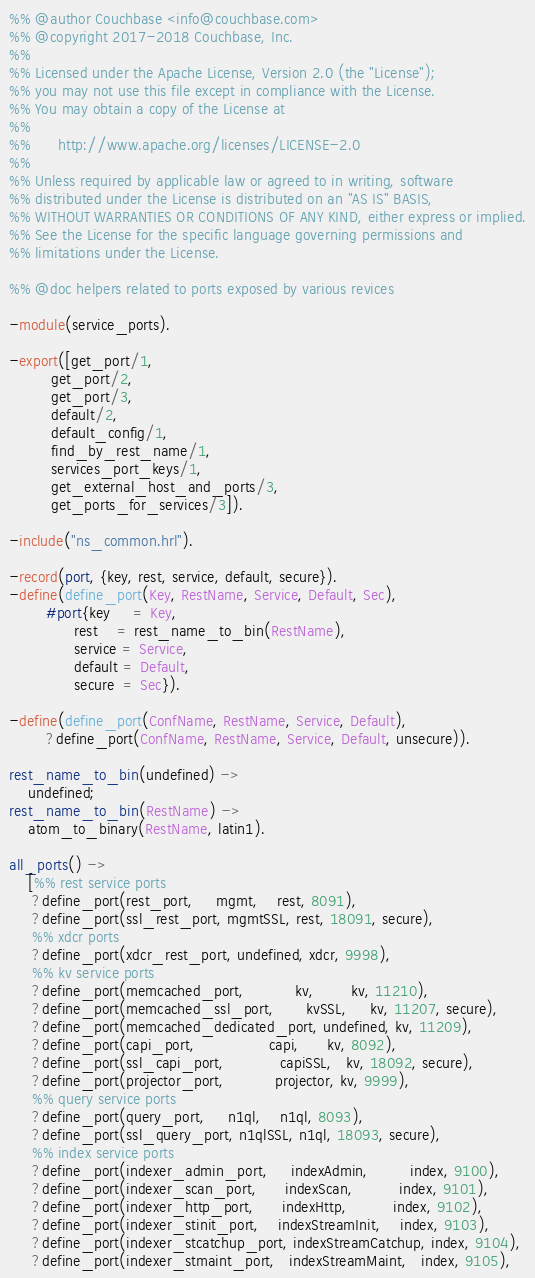<code> <loc_0><loc_0><loc_500><loc_500><_Erlang_>%% @author Couchbase <info@couchbase.com>
%% @copyright 2017-2018 Couchbase, Inc.
%%
%% Licensed under the Apache License, Version 2.0 (the "License");
%% you may not use this file except in compliance with the License.
%% You may obtain a copy of the License at
%%
%%      http://www.apache.org/licenses/LICENSE-2.0
%%
%% Unless required by applicable law or agreed to in writing, software
%% distributed under the License is distributed on an "AS IS" BASIS,
%% WITHOUT WARRANTIES OR CONDITIONS OF ANY KIND, either express or implied.
%% See the License for the specific language governing permissions and
%% limitations under the License.

%% @doc helpers related to ports exposed by various revices

-module(service_ports).

-export([get_port/1,
         get_port/2,
         get_port/3,
         default/2,
         default_config/1,
         find_by_rest_name/1,
         services_port_keys/1,
         get_external_host_and_ports/3,
         get_ports_for_services/3]).

-include("ns_common.hrl").

-record(port, {key, rest, service, default, secure}).
-define(define_port(Key, RestName, Service, Default, Sec),
        #port{key     = Key,
              rest    = rest_name_to_bin(RestName),
              service = Service,
              default = Default,
              secure  = Sec}).

-define(define_port(ConfName, RestName, Service, Default),
        ?define_port(ConfName, RestName, Service, Default, unsecure)).

rest_name_to_bin(undefined) ->
    undefined;
rest_name_to_bin(RestName) ->
    atom_to_binary(RestName, latin1).

all_ports() ->
    [%% rest service ports
     ?define_port(rest_port,     mgmt,    rest, 8091),
     ?define_port(ssl_rest_port, mgmtSSL, rest, 18091, secure),
     %% xdcr ports
     ?define_port(xdcr_rest_port, undefined, xdcr, 9998),
     %% kv service ports
     ?define_port(memcached_port,           kv,        kv, 11210),
     ?define_port(memcached_ssl_port,       kvSSL,     kv, 11207, secure),
     ?define_port(memcached_dedicated_port, undefined, kv, 11209),
     ?define_port(capi_port,                capi,      kv, 8092),
     ?define_port(ssl_capi_port,            capiSSL,   kv, 18092, secure),
     ?define_port(projector_port,           projector, kv, 9999),
     %% query service ports
     ?define_port(query_port,     n1ql,    n1ql, 8093),
     ?define_port(ssl_query_port, n1qlSSL, n1ql, 18093, secure),
     %% index service ports
     ?define_port(indexer_admin_port,     indexAdmin,         index, 9100),
     ?define_port(indexer_scan_port,      indexScan,          index, 9101),
     ?define_port(indexer_http_port,      indexHttp,          index, 9102),
     ?define_port(indexer_stinit_port,    indexStreamInit,    index, 9103),
     ?define_port(indexer_stcatchup_port, indexStreamCatchup, index, 9104),
     ?define_port(indexer_stmaint_port,   indexStreamMaint,   index, 9105),</code> 